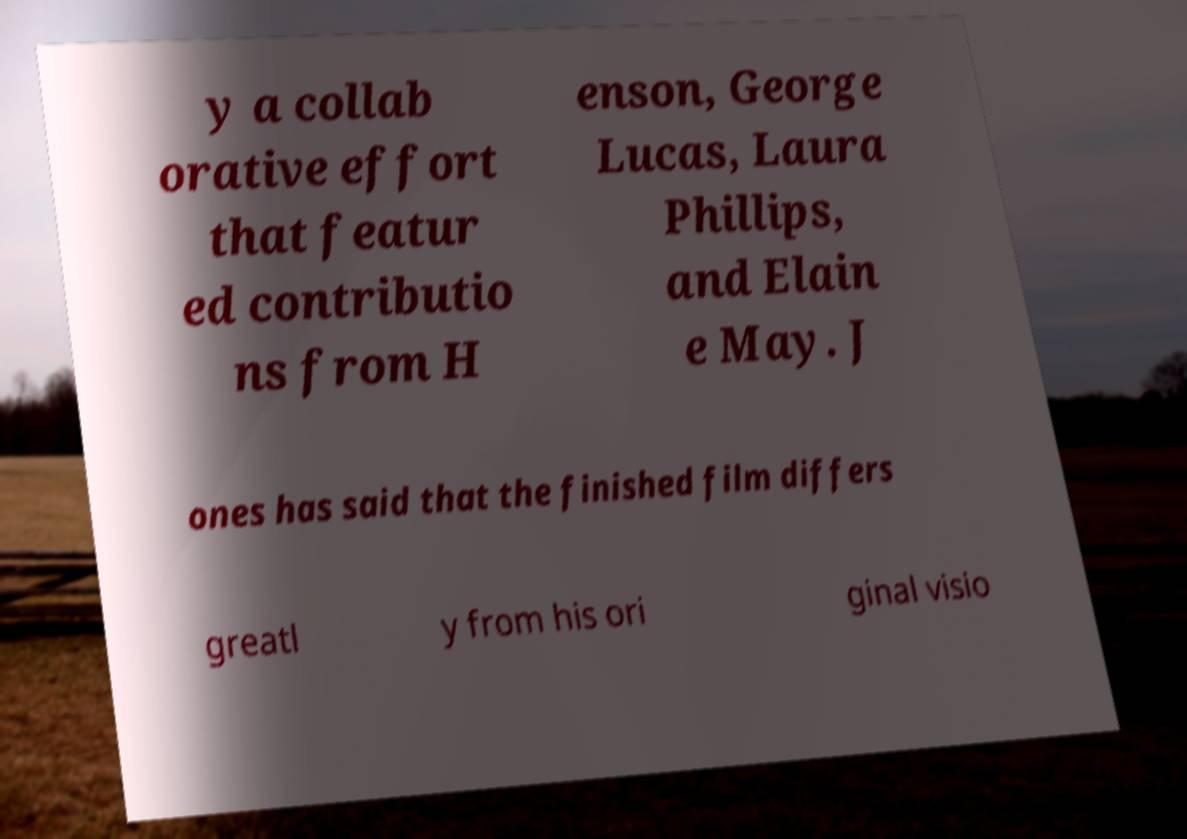Can you accurately transcribe the text from the provided image for me? y a collab orative effort that featur ed contributio ns from H enson, George Lucas, Laura Phillips, and Elain e May. J ones has said that the finished film differs greatl y from his ori ginal visio 